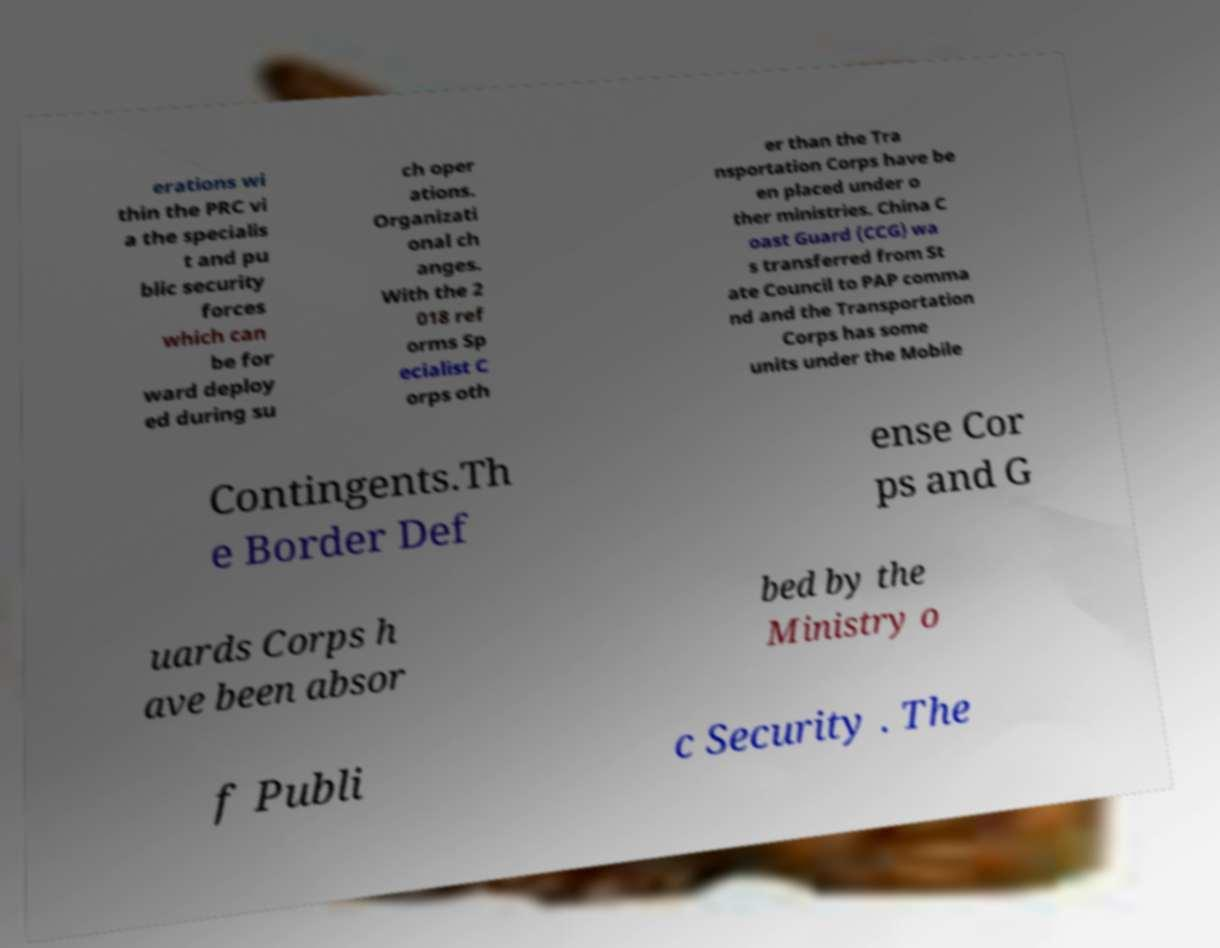Please read and relay the text visible in this image. What does it say? erations wi thin the PRC vi a the specialis t and pu blic security forces which can be for ward deploy ed during su ch oper ations. Organizati onal ch anges. With the 2 018 ref orms Sp ecialist C orps oth er than the Tra nsportation Corps have be en placed under o ther ministries. China C oast Guard (CCG) wa s transferred from St ate Council to PAP comma nd and the Transportation Corps has some units under the Mobile Contingents.Th e Border Def ense Cor ps and G uards Corps h ave been absor bed by the Ministry o f Publi c Security . The 